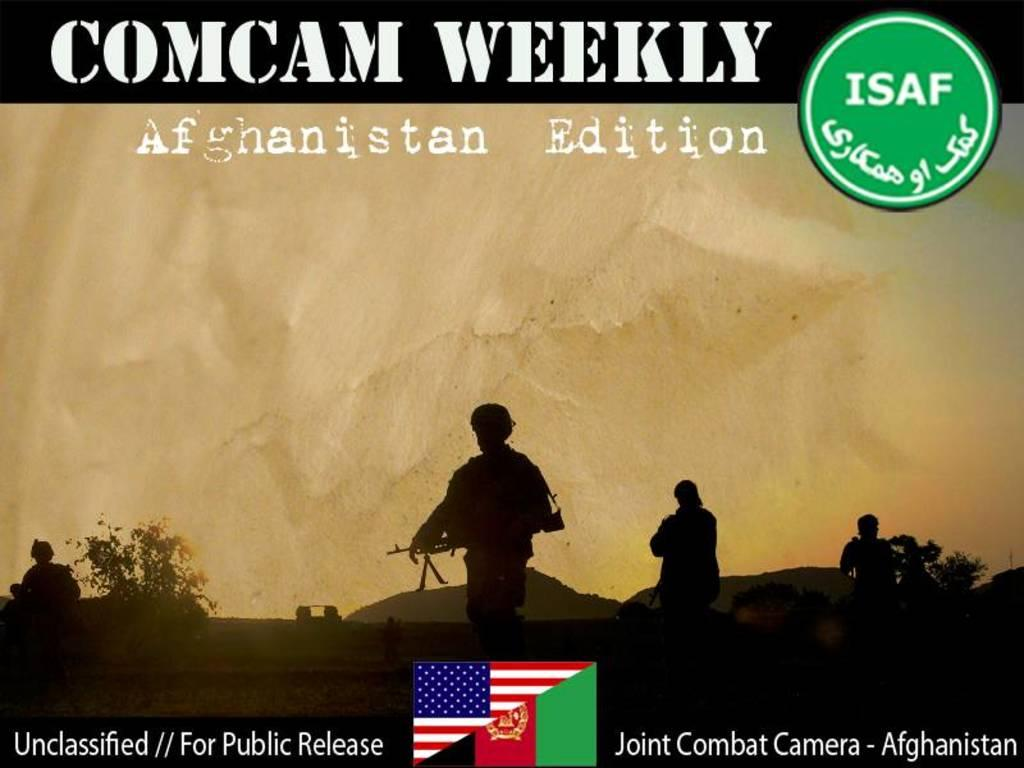Provide a one-sentence caption for the provided image. The cover of Comcam Weekly Afghanistan Edition depicting soldiers. 